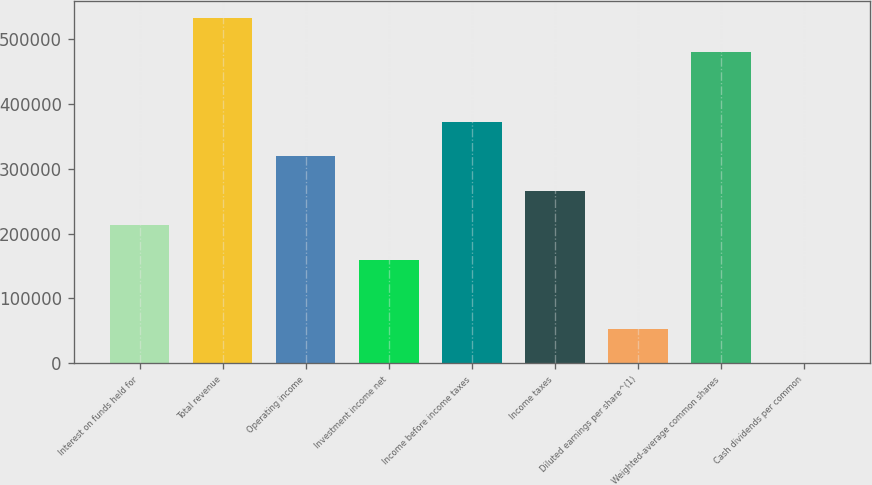<chart> <loc_0><loc_0><loc_500><loc_500><bar_chart><fcel>Interest on funds held for<fcel>Total revenue<fcel>Operating income<fcel>Investment income net<fcel>Income before income taxes<fcel>Income taxes<fcel>Diluted earnings per share^(1)<fcel>Weighted-average common shares<fcel>Cash dividends per common<nl><fcel>212869<fcel>532172<fcel>319303<fcel>159652<fcel>372520<fcel>266086<fcel>53217.5<fcel>478955<fcel>0.3<nl></chart> 